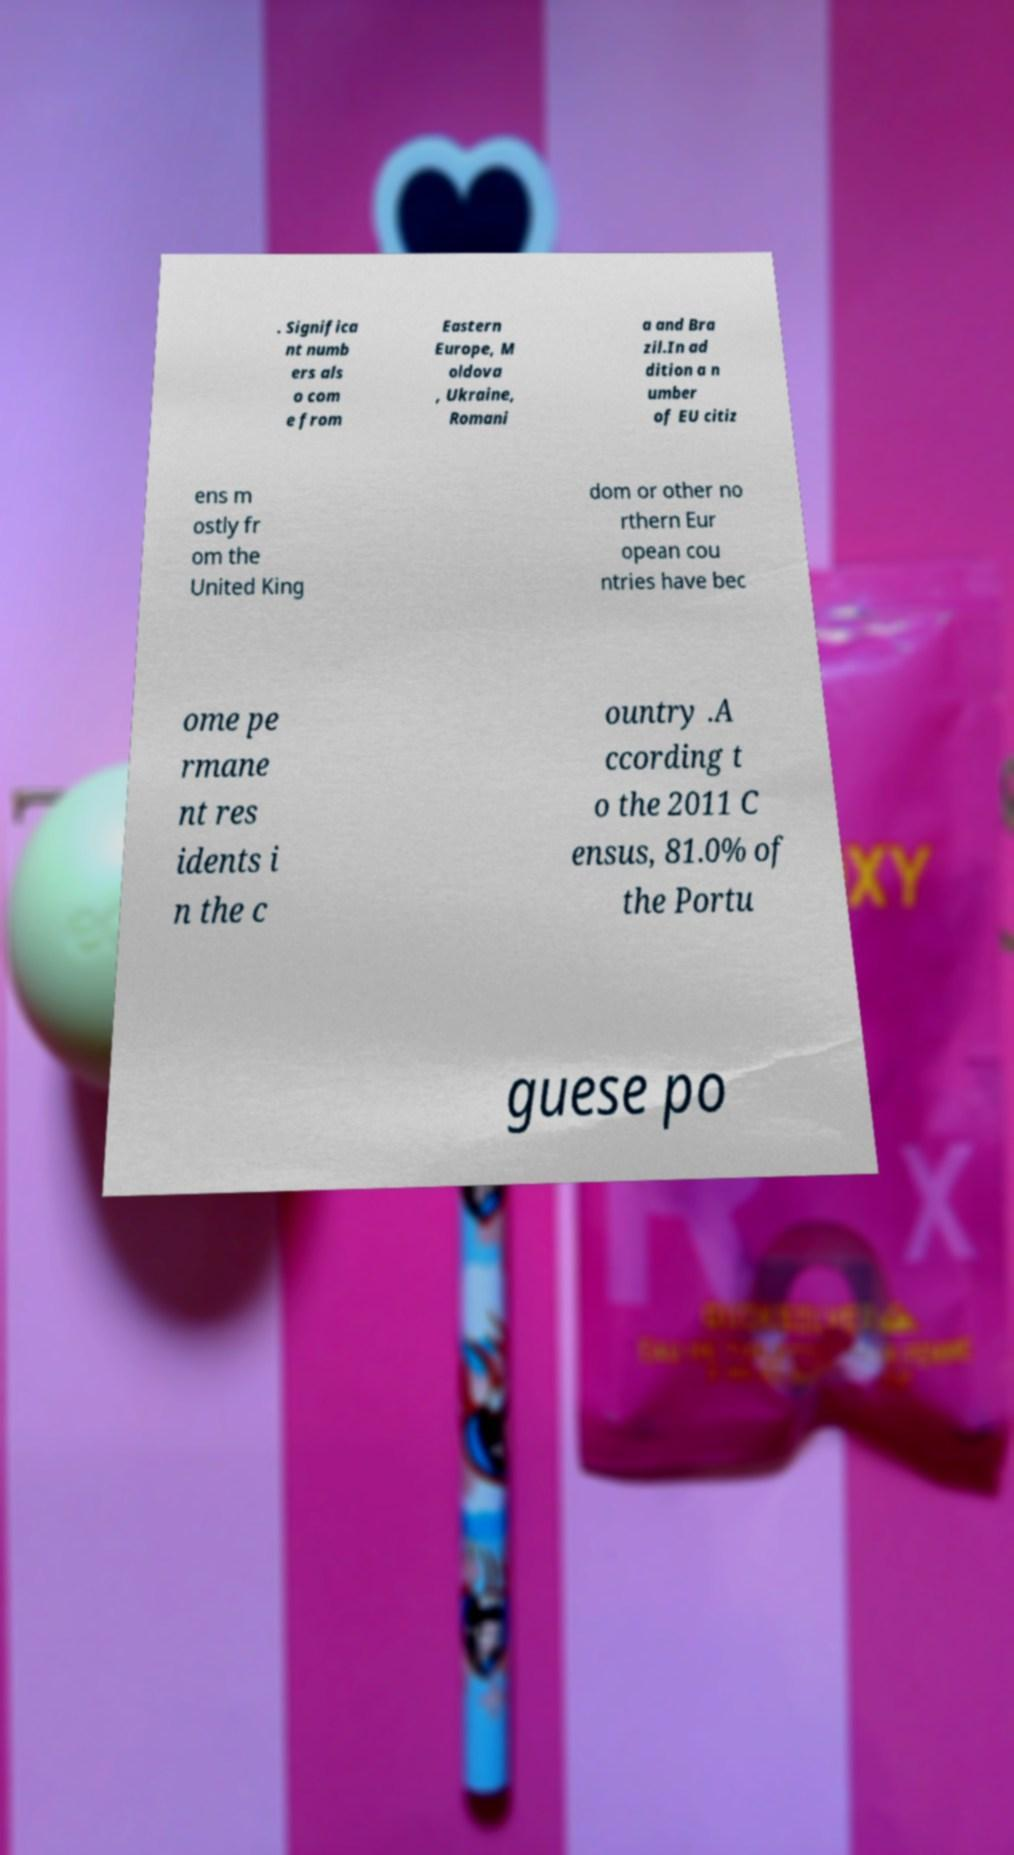Please identify and transcribe the text found in this image. . Significa nt numb ers als o com e from Eastern Europe, M oldova , Ukraine, Romani a and Bra zil.In ad dition a n umber of EU citiz ens m ostly fr om the United King dom or other no rthern Eur opean cou ntries have bec ome pe rmane nt res idents i n the c ountry .A ccording t o the 2011 C ensus, 81.0% of the Portu guese po 